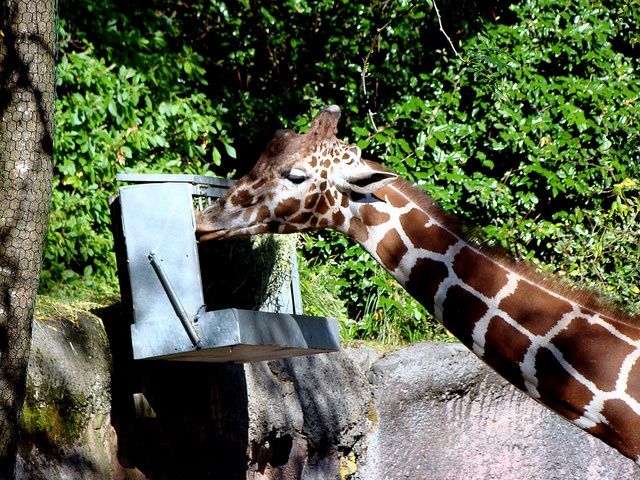Describe the objects in this image and their specific colors. I can see a giraffe in black, maroon, white, and gray tones in this image. 